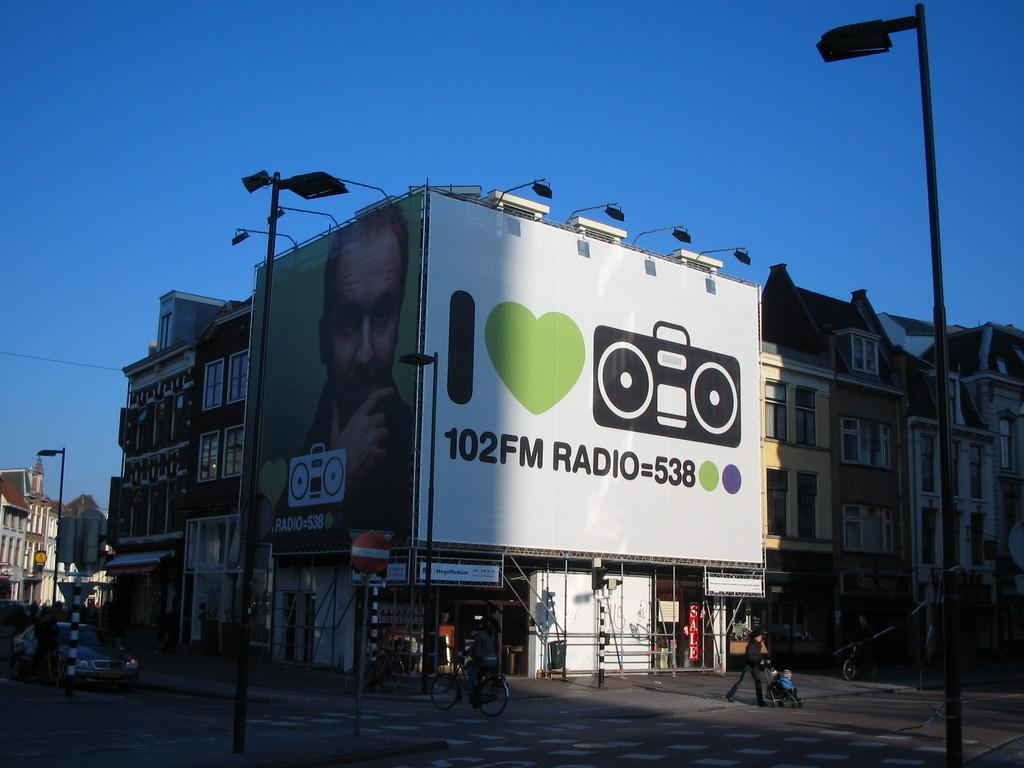<image>
Summarize the visual content of the image. The ad is for the radio station 102FM 